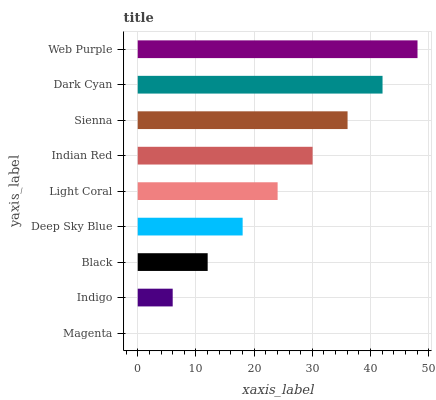Is Magenta the minimum?
Answer yes or no. Yes. Is Web Purple the maximum?
Answer yes or no. Yes. Is Indigo the minimum?
Answer yes or no. No. Is Indigo the maximum?
Answer yes or no. No. Is Indigo greater than Magenta?
Answer yes or no. Yes. Is Magenta less than Indigo?
Answer yes or no. Yes. Is Magenta greater than Indigo?
Answer yes or no. No. Is Indigo less than Magenta?
Answer yes or no. No. Is Light Coral the high median?
Answer yes or no. Yes. Is Light Coral the low median?
Answer yes or no. Yes. Is Indigo the high median?
Answer yes or no. No. Is Dark Cyan the low median?
Answer yes or no. No. 